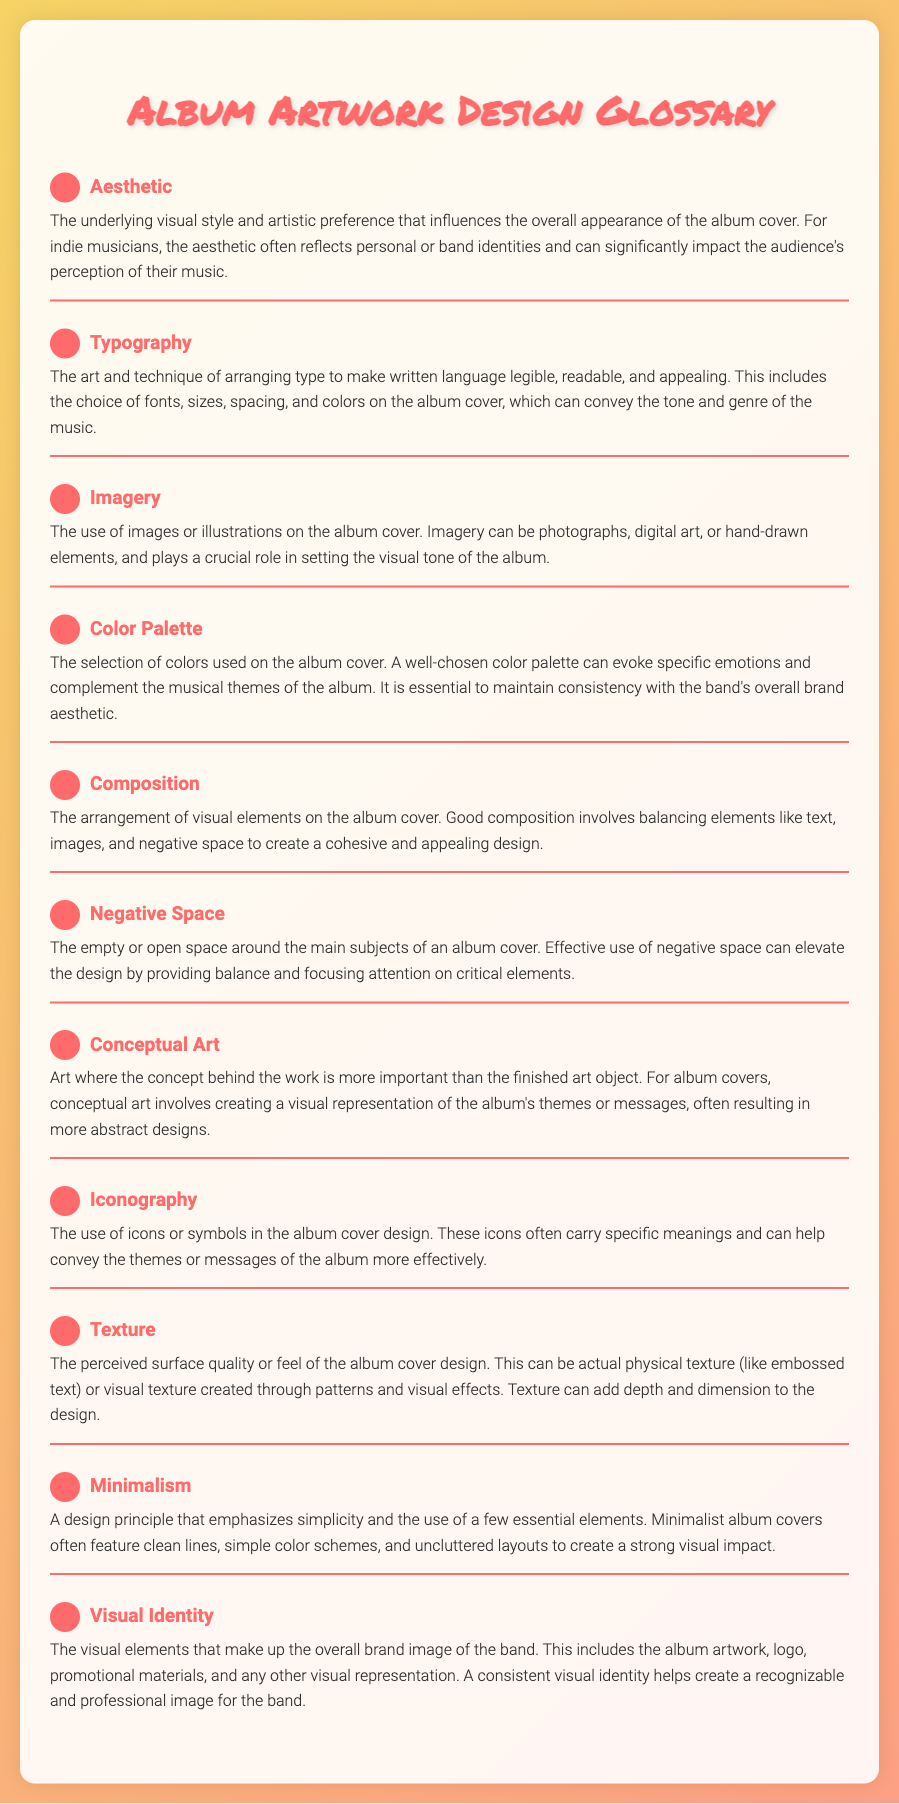What is the term for the underlying visual style of an album cover? The term refers to the aesthetic, which influences the overall appearance of the album cover.
Answer: Aesthetic Which design principle emphasizes simplicity and essential elements? This principle is known as minimalism, which creates a strong visual impact.
Answer: Minimalism What plays a crucial role in setting the visual tone of the album? The use of images or illustrations, referred to as imagery, greatly contributes to the tone.
Answer: Imagery What is the selection of colors used on the album cover called? This selection is known as the color palette, which evokes emotions and complements musical themes.
Answer: Color Palette What is the perceived surface quality or feel of the album cover design? This quality is referred to as texture and can add depth and dimension to the design.
Answer: Texture How does good composition affect an album's visual design? Good composition balances elements like text, images, and negative space to create an appealing design.
Answer: Composition What kind of art focuses on the concept behind the work rather than the finished object? This type of art is called conceptual art, which often results in abstract designs for album covers.
Answer: Conceptual Art What encompasses the overall brand image of a band visually? This encompasses visual identity, which includes album artwork, logo, and promotional materials.
Answer: Visual Identity What aspect of album cover design provides balance and focuses attention? This aspect is known as negative space, which enhances design effectiveness.
Answer: Negative Space 